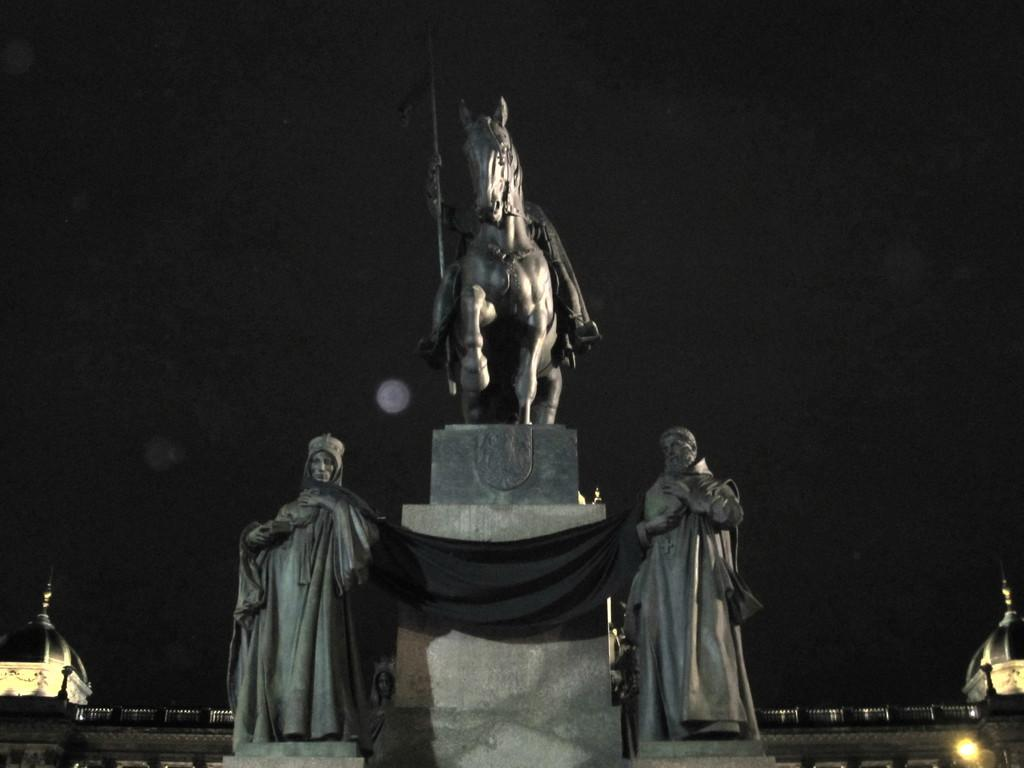What type of artwork can be seen in the image? There are sculptures in the image. What can be used to illuminate the sculptures in the image? There is a light in the image. How would you describe the overall lighting in the image? The background of the image is dark. How many people are walking in the image? There are no people visible in the image, only sculptures. What type of military vehicle can be seen in the image? There is no military vehicle present in the image. 